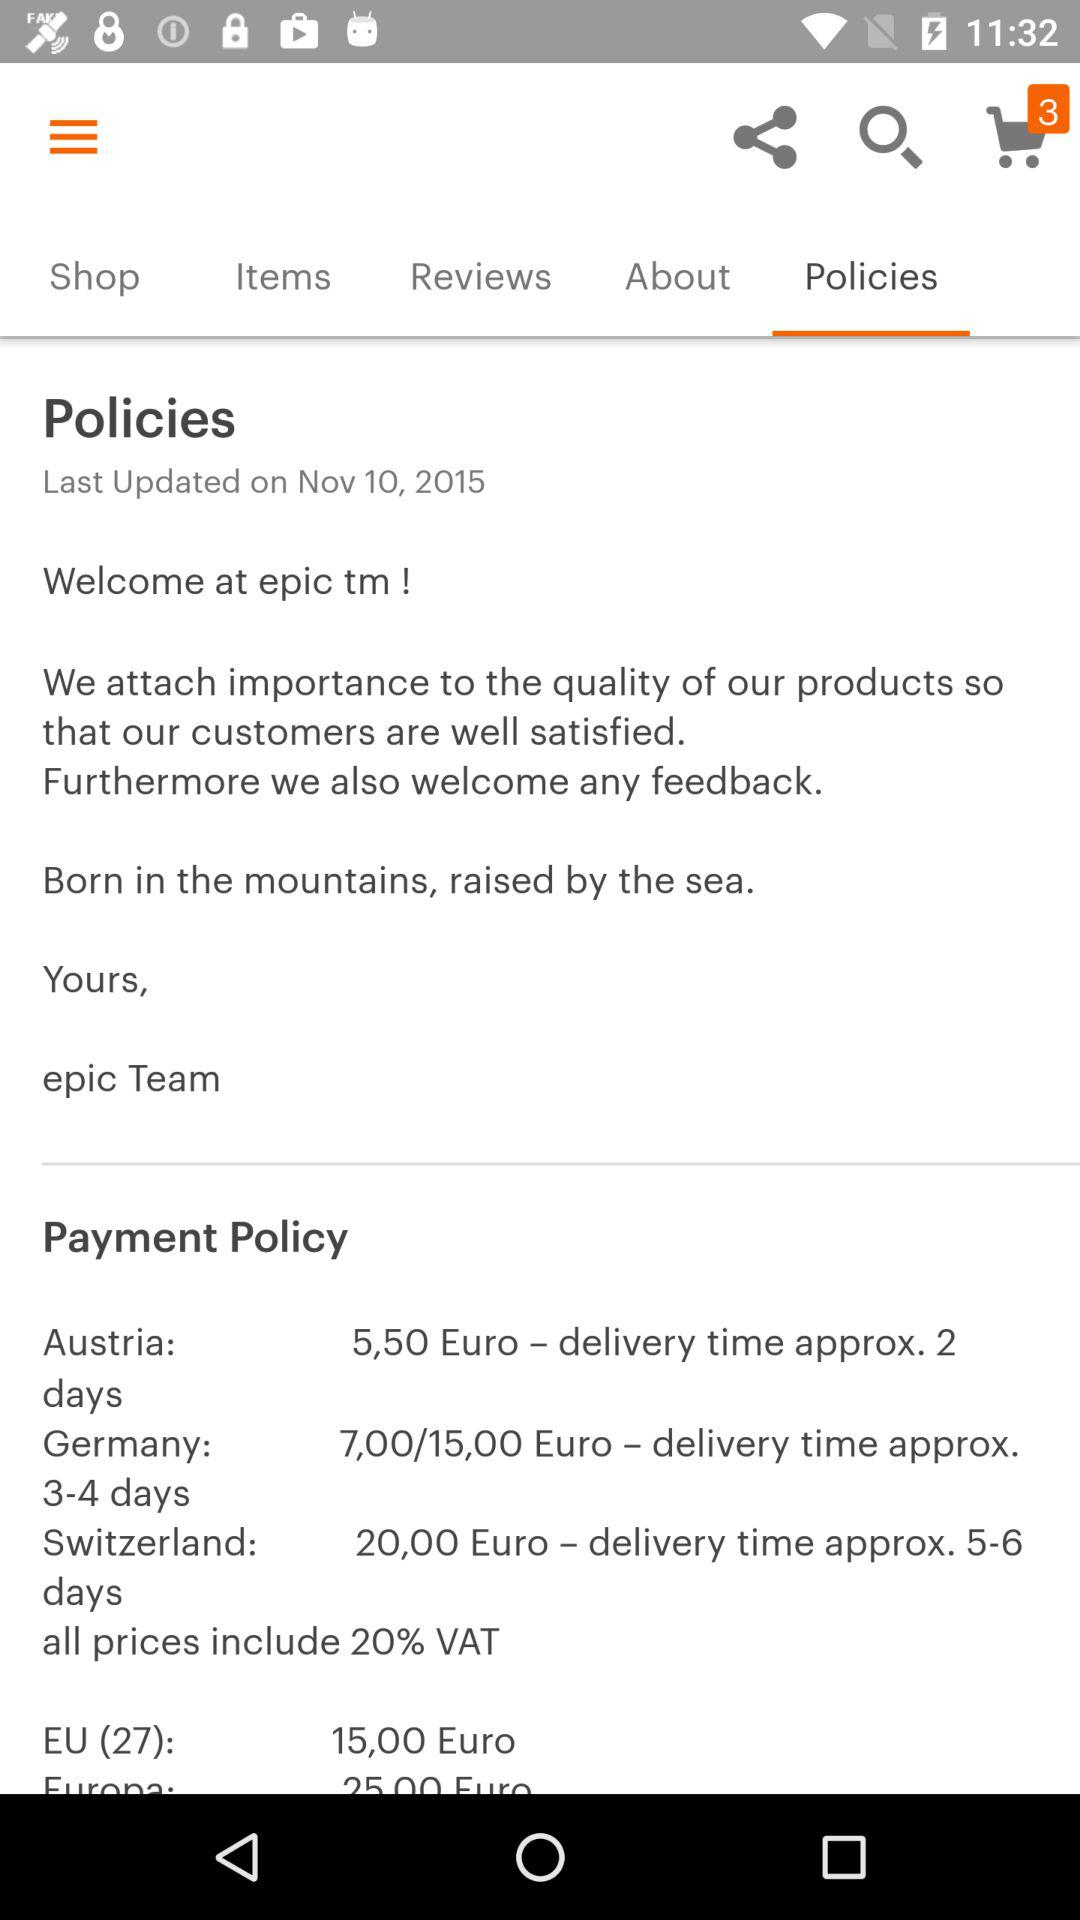What is the maximum delivery time for an order in Switzerland?
Answer the question using a single word or phrase. 6 days 